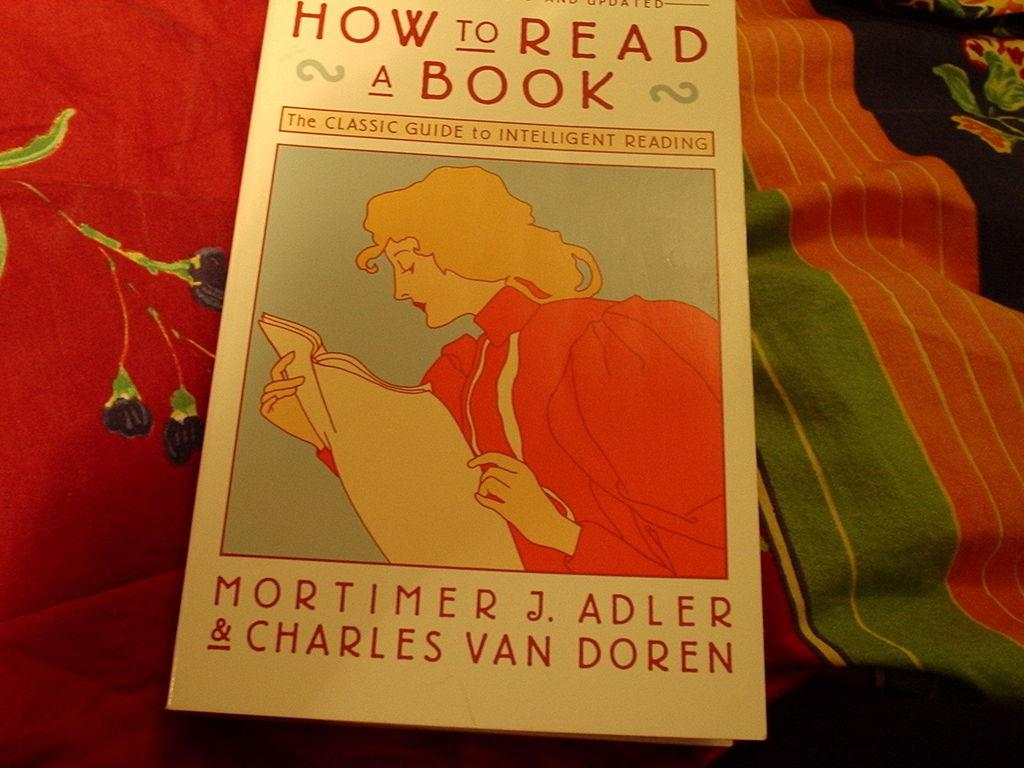<image>
Relay a brief, clear account of the picture shown. A guide of how to read is on top of a couple of blankets. 